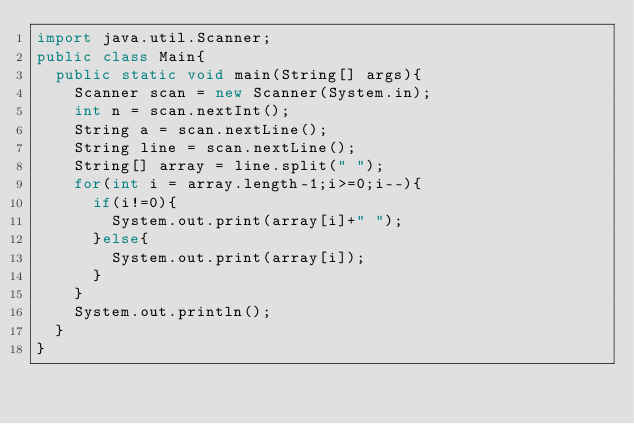Convert code to text. <code><loc_0><loc_0><loc_500><loc_500><_Java_>import java.util.Scanner;
public class Main{
	public static void main(String[] args){
		Scanner scan = new Scanner(System.in);
		int n = scan.nextInt();
		String a = scan.nextLine();
		String line = scan.nextLine();
		String[] array = line.split(" ");
		for(int i = array.length-1;i>=0;i--){
			if(i!=0){
				System.out.print(array[i]+" ");
			}else{
				System.out.print(array[i]);
			}
		}
		System.out.println();
	}
}</code> 